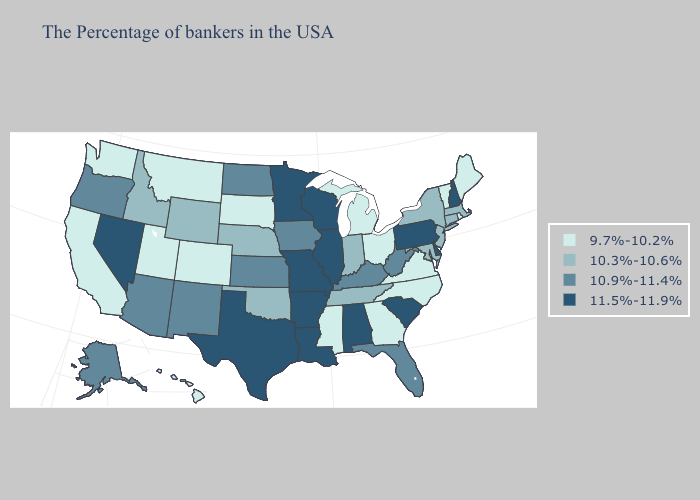Name the states that have a value in the range 11.5%-11.9%?
Short answer required. New Hampshire, Delaware, Pennsylvania, South Carolina, Alabama, Wisconsin, Illinois, Louisiana, Missouri, Arkansas, Minnesota, Texas, Nevada. Name the states that have a value in the range 10.9%-11.4%?
Quick response, please. West Virginia, Florida, Kentucky, Iowa, Kansas, North Dakota, New Mexico, Arizona, Oregon, Alaska. Name the states that have a value in the range 11.5%-11.9%?
Quick response, please. New Hampshire, Delaware, Pennsylvania, South Carolina, Alabama, Wisconsin, Illinois, Louisiana, Missouri, Arkansas, Minnesota, Texas, Nevada. Among the states that border Wyoming , does Idaho have the lowest value?
Concise answer only. No. How many symbols are there in the legend?
Keep it brief. 4. Which states have the highest value in the USA?
Be succinct. New Hampshire, Delaware, Pennsylvania, South Carolina, Alabama, Wisconsin, Illinois, Louisiana, Missouri, Arkansas, Minnesota, Texas, Nevada. What is the value of Delaware?
Keep it brief. 11.5%-11.9%. What is the value of Utah?
Answer briefly. 9.7%-10.2%. Which states have the lowest value in the South?
Concise answer only. Virginia, North Carolina, Georgia, Mississippi. Name the states that have a value in the range 10.3%-10.6%?
Quick response, please. Massachusetts, Connecticut, New York, New Jersey, Maryland, Indiana, Tennessee, Nebraska, Oklahoma, Wyoming, Idaho. Name the states that have a value in the range 10.3%-10.6%?
Be succinct. Massachusetts, Connecticut, New York, New Jersey, Maryland, Indiana, Tennessee, Nebraska, Oklahoma, Wyoming, Idaho. Name the states that have a value in the range 10.9%-11.4%?
Concise answer only. West Virginia, Florida, Kentucky, Iowa, Kansas, North Dakota, New Mexico, Arizona, Oregon, Alaska. Does the map have missing data?
Concise answer only. No. Name the states that have a value in the range 11.5%-11.9%?
Write a very short answer. New Hampshire, Delaware, Pennsylvania, South Carolina, Alabama, Wisconsin, Illinois, Louisiana, Missouri, Arkansas, Minnesota, Texas, Nevada. What is the highest value in the USA?
Concise answer only. 11.5%-11.9%. 